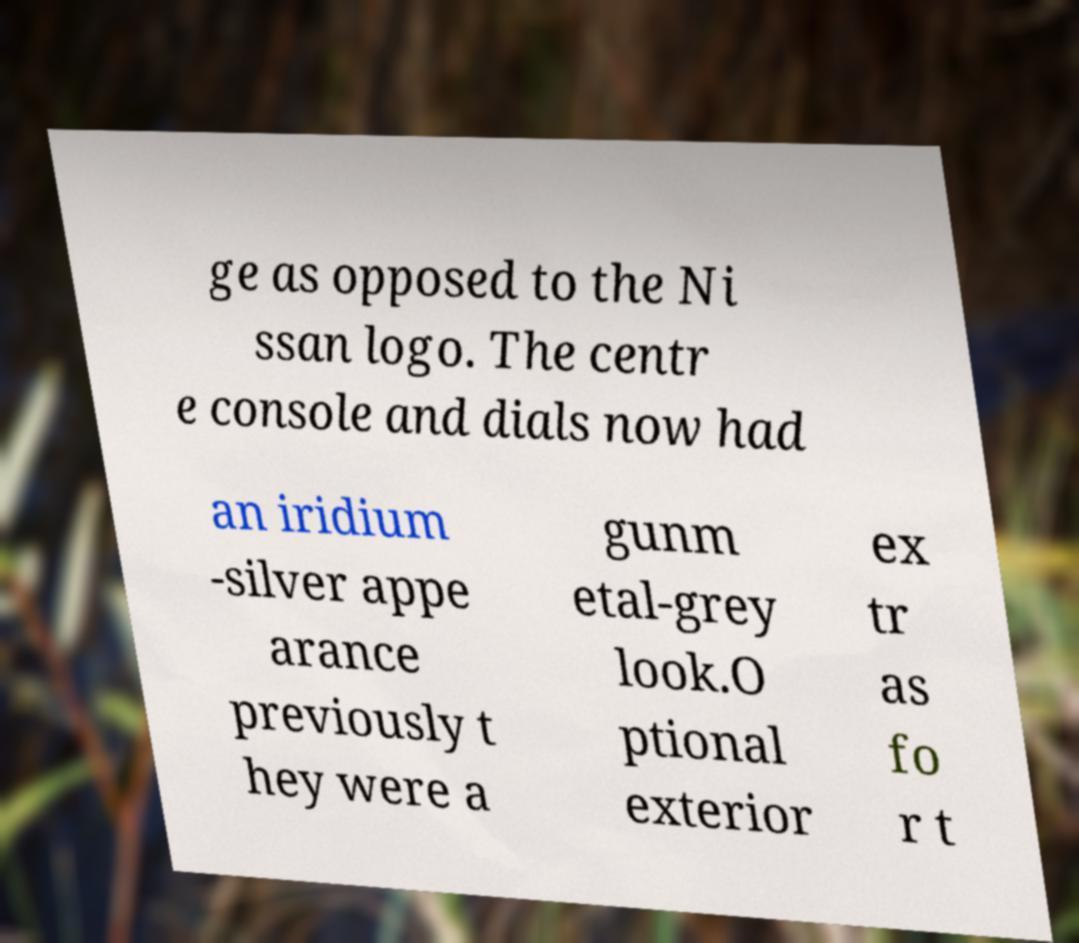There's text embedded in this image that I need extracted. Can you transcribe it verbatim? ge as opposed to the Ni ssan logo. The centr e console and dials now had an iridium -silver appe arance previously t hey were a gunm etal-grey look.O ptional exterior ex tr as fo r t 